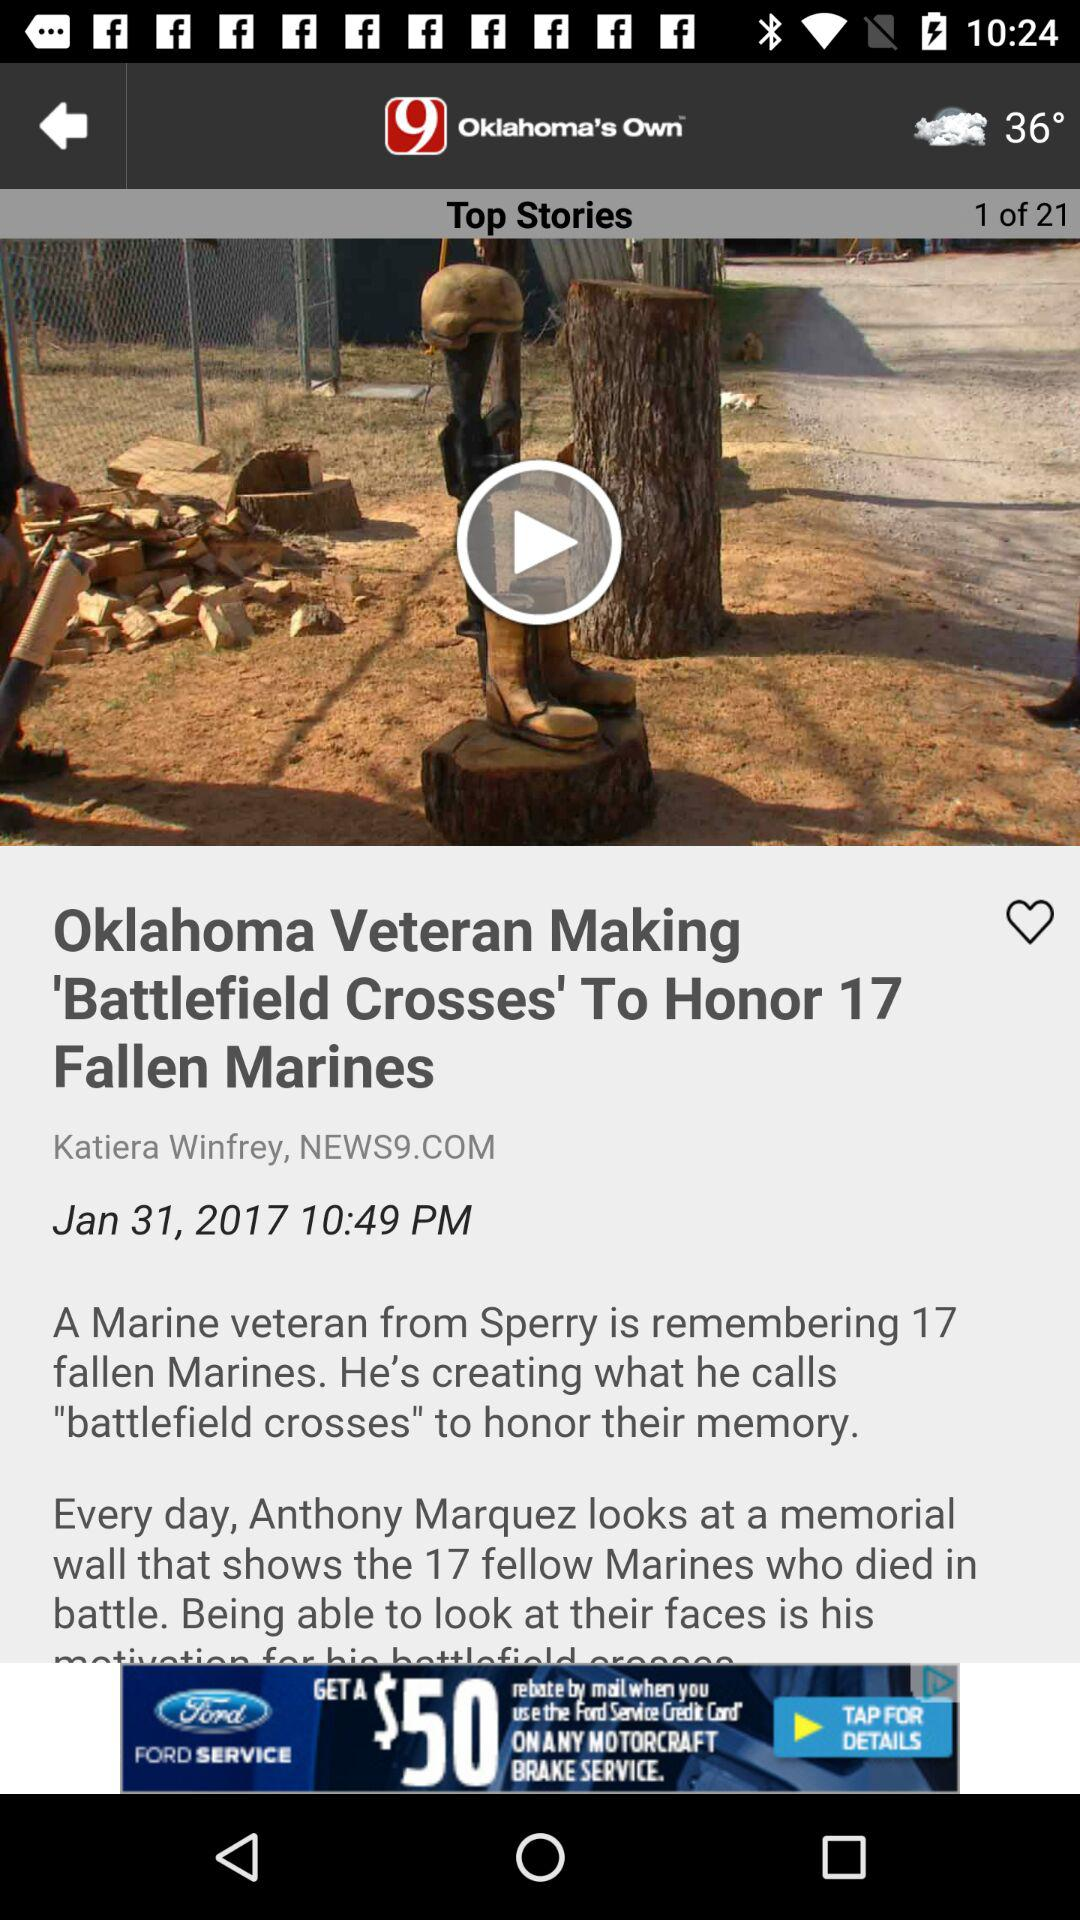Who is the author of the article Oklahoma Veteran Making 'Battlefield Crosses'? The author is Katiera Winfrey. 